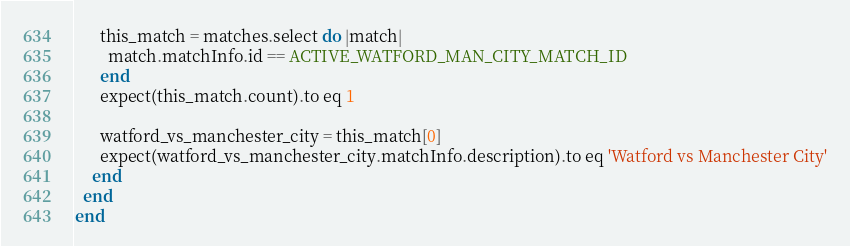Convert code to text. <code><loc_0><loc_0><loc_500><loc_500><_Ruby_>
      this_match = matches.select do |match|
        match.matchInfo.id == ACTIVE_WATFORD_MAN_CITY_MATCH_ID
      end
      expect(this_match.count).to eq 1

      watford_vs_manchester_city = this_match[0]
      expect(watford_vs_manchester_city.matchInfo.description).to eq 'Watford vs Manchester City'
    end
  end
end
</code> 